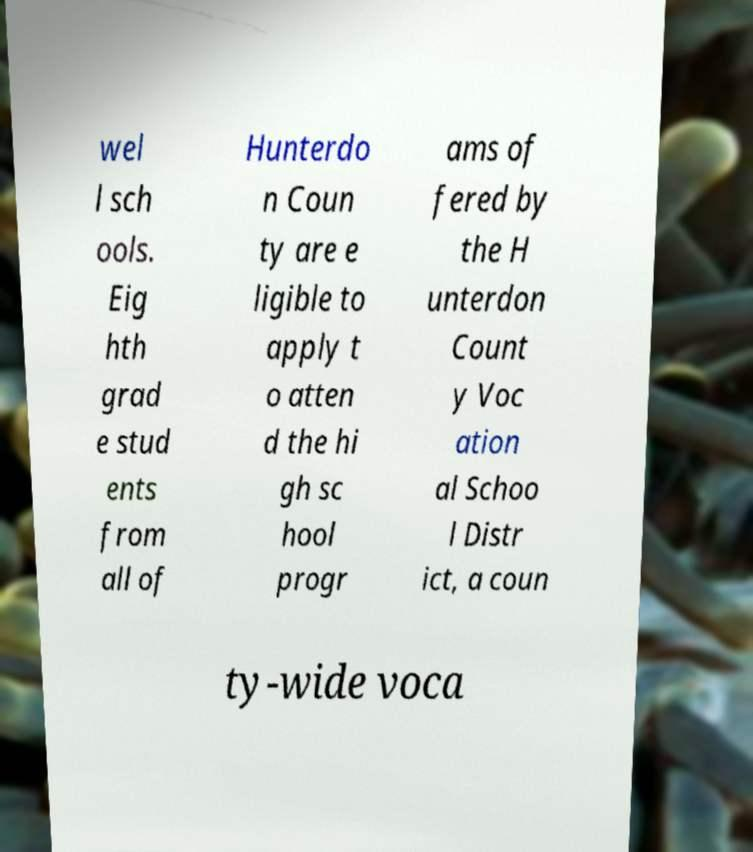Can you read and provide the text displayed in the image?This photo seems to have some interesting text. Can you extract and type it out for me? wel l sch ools. Eig hth grad e stud ents from all of Hunterdo n Coun ty are e ligible to apply t o atten d the hi gh sc hool progr ams of fered by the H unterdon Count y Voc ation al Schoo l Distr ict, a coun ty-wide voca 